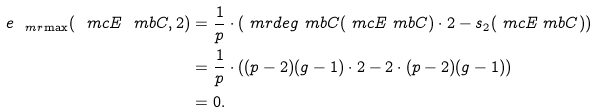Convert formula to latex. <formula><loc_0><loc_0><loc_500><loc_500>e _ { \ m r { \max } } ( \ m c E _ { \ } m b C , 2 ) = & \ \frac { 1 } { p } \cdot ( \ m r { d e g } _ { \ } m b C ( \ m c E _ { \ } m b C ) \cdot 2 - s _ { 2 } ( \ m c E _ { \ } m b C ) ) \\ = & \ \frac { 1 } { p } \cdot ( ( p - 2 ) ( g - 1 ) \cdot 2 - 2 \cdot ( p - 2 ) ( g - 1 ) ) \\ = & \ 0 .</formula> 